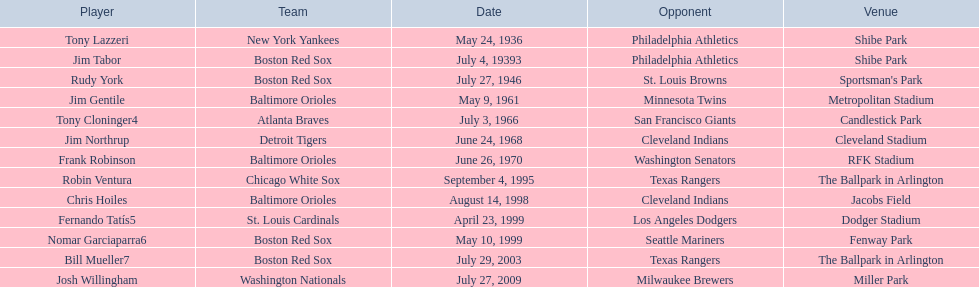What are the dates? May 24, 1936, July 4, 19393, July 27, 1946, May 9, 1961, July 3, 1966, June 24, 1968, June 26, 1970, September 4, 1995, August 14, 1998, April 23, 1999, May 10, 1999, July 29, 2003, July 27, 2009. Which date is in 1936? May 24, 1936. What player is listed for this date? Tony Lazzeri. 